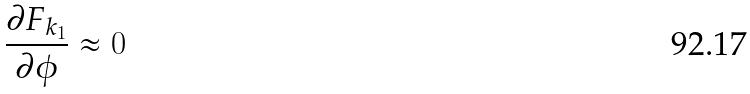Convert formula to latex. <formula><loc_0><loc_0><loc_500><loc_500>\frac { \partial F _ { k _ { 1 } } } { \partial \phi } \approx 0</formula> 